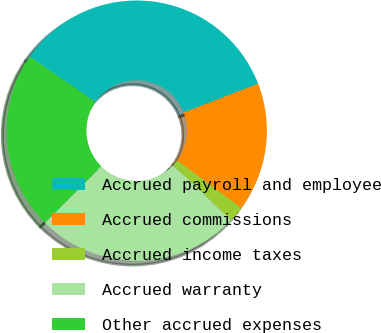<chart> <loc_0><loc_0><loc_500><loc_500><pie_chart><fcel>Accrued payroll and employee<fcel>Accrued commissions<fcel>Accrued income taxes<fcel>Accrued warranty<fcel>Other accrued expenses<nl><fcel>34.5%<fcel>16.01%<fcel>1.95%<fcel>25.4%<fcel>22.14%<nl></chart> 